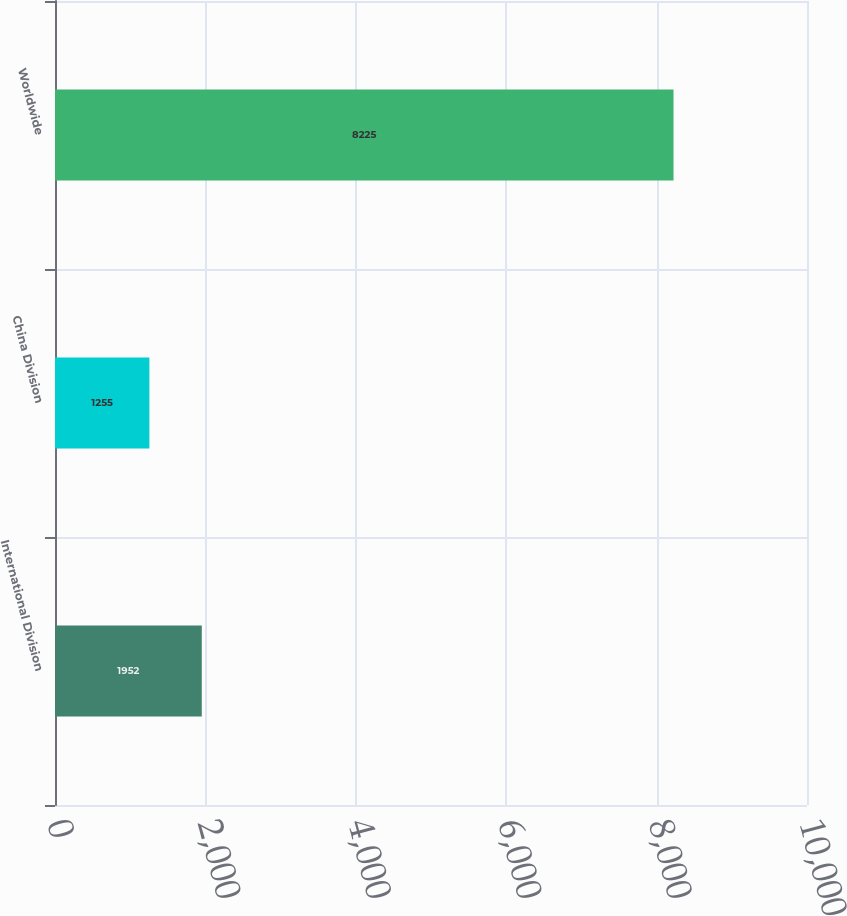<chart> <loc_0><loc_0><loc_500><loc_500><bar_chart><fcel>International Division<fcel>China Division<fcel>Worldwide<nl><fcel>1952<fcel>1255<fcel>8225<nl></chart> 